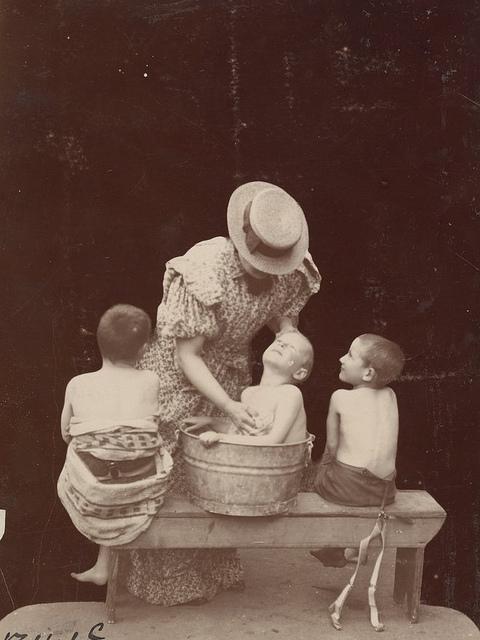What is the best description for this type of photo?
Answer briefly. Sepia. What kind of hat is the woman wearing?
Answer briefly. Straw. How many children are in this photo?
Short answer required. 3. 